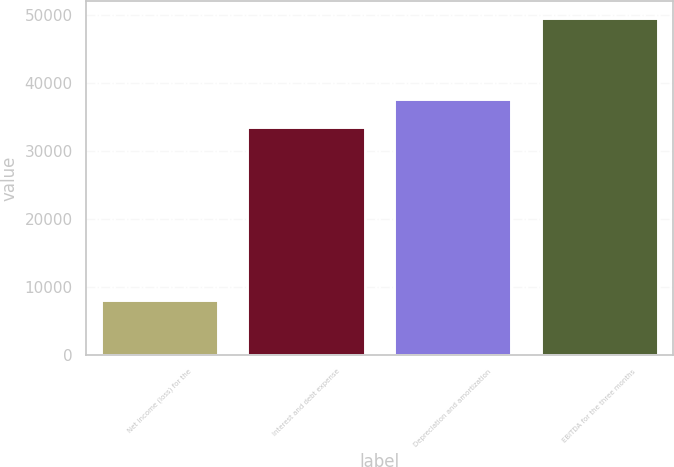Convert chart to OTSL. <chart><loc_0><loc_0><loc_500><loc_500><bar_chart><fcel>Net income (loss) for the<fcel>Interest and debt expense<fcel>Depreciation and amortization<fcel>EBITDA for the three months<nl><fcel>8141<fcel>33569<fcel>37718.8<fcel>49639<nl></chart> 